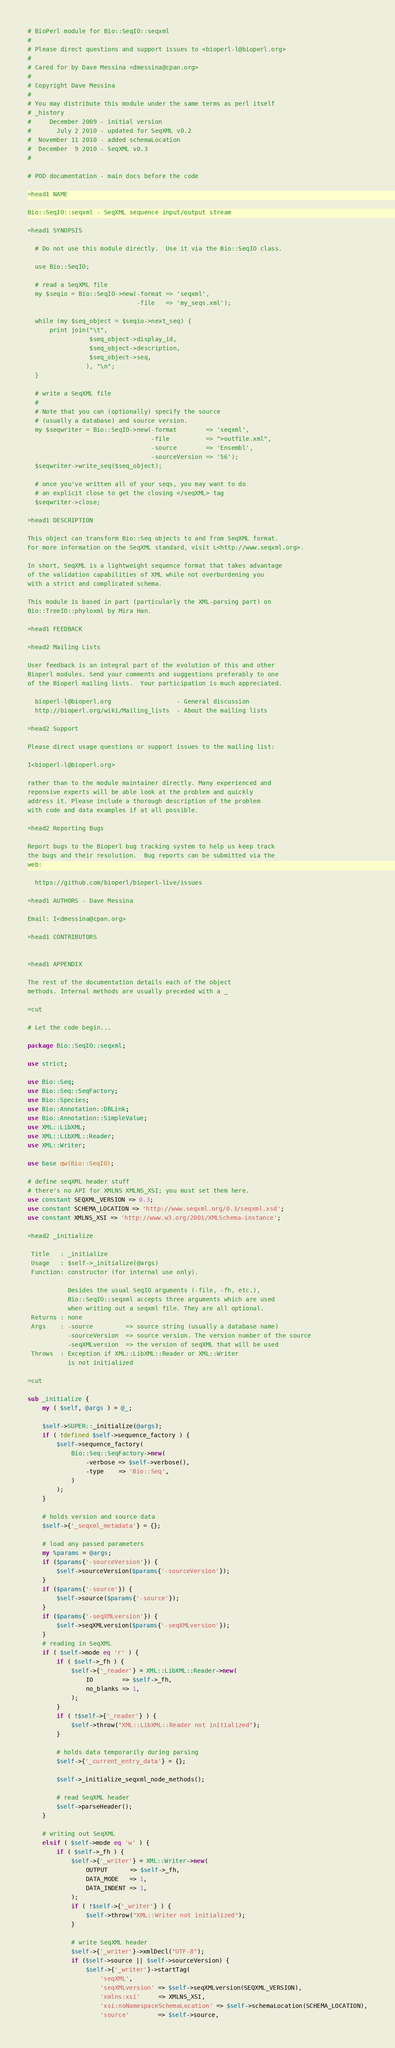Convert code to text. <code><loc_0><loc_0><loc_500><loc_500><_Perl_># BioPerl module for Bio::SeqIO::seqxml
#
# Please direct questions and support issues to <bioperl-l@bioperl.org>
#
# Cared for by Dave Messina <dmessina@cpan.org>
#
# Copyright Dave Messina
#
# You may distribute this module under the same terms as perl itself
# _history
#     December 2009 - initial version
#       July 2 2010 - updated for SeqXML v0.2
#  November 11 2010 - added schemaLocation
#  December  9 2010 - SeqXML v0.3
# 

# POD documentation - main docs before the code

=head1 NAME

Bio::SeqIO::seqxml - SeqXML sequence input/output stream

=head1 SYNOPSIS

  # Do not use this module directly.  Use it via the Bio::SeqIO class.

  use Bio::SeqIO;
  
  # read a SeqXML file
  my $seqio = Bio::SeqIO->new(-format => 'seqxml',
                              -file   => 'my_seqs.xml');

  while (my $seq_object = $seqio->next_seq) {
      print join("\t", 
                 $seq_object->display_id,
                 $seq_object->description,
                 $seq_object->seq,           
                ), "\n";
  }
  
  # write a SeqXML file
  #
  # Note that you can (optionally) specify the source
  # (usually a database) and source version.
  my $seqwriter = Bio::SeqIO->new(-format        => 'seqxml',
                                  -file          => ">outfile.xml",
                                  -source        => 'Ensembl',
                                  -sourceVersion => '56');
  $seqwriter->write_seq($seq_object);

  # once you've written all of your seqs, you may want to do
  # an explicit close to get the closing </seqXML> tag
  $seqwriter->close; 

=head1 DESCRIPTION

This object can transform Bio::Seq objects to and from SeqXML format.
For more information on the SeqXML standard, visit L<http://www.seqxml.org>.

In short, SeqXML is a lightweight sequence format that takes advantage
of the validation capabilities of XML while not overburdening you
with a strict and complicated schema.

This module is based in part (particularly the XML-parsing part) on 
Bio::TreeIO::phyloxml by Mira Han.

=head1 FEEDBACK

=head2 Mailing Lists

User feedback is an integral part of the evolution of this and other
Bioperl modules. Send your comments and suggestions preferably to one
of the Bioperl mailing lists.  Your participation is much appreciated.

  bioperl-l@bioperl.org                  - General discussion
  http://bioperl.org/wiki/Mailing_lists  - About the mailing lists

=head2 Support 

Please direct usage questions or support issues to the mailing list:

I<bioperl-l@bioperl.org>

rather than to the module maintainer directly. Many experienced and 
reponsive experts will be able look at the problem and quickly 
address it. Please include a thorough description of the problem 
with code and data examples if at all possible.

=head2 Reporting Bugs

Report bugs to the Bioperl bug tracking system to help us keep track
the bugs and their resolution.  Bug reports can be submitted via the
web:

  https://github.com/bioperl/bioperl-live/issues

=head1 AUTHORS - Dave Messina

Email: I<dmessina@cpan.org>

=head1 CONTRIBUTORS


=head1 APPENDIX

The rest of the documentation details each of the object
methods. Internal methods are usually preceded with a _

=cut

# Let the code begin...

package Bio::SeqIO::seqxml;

use strict;

use Bio::Seq;
use Bio::Seq::SeqFactory;
use Bio::Species;
use Bio::Annotation::DBLink;
use Bio::Annotation::SimpleValue;
use XML::LibXML;
use XML::LibXML::Reader;
use XML::Writer;

use base qw(Bio::SeqIO);

# define seqXML header stuff
# there's no API for XMLNS XMLNS_XSI; you must set them here.
use constant SEQXML_VERSION => 0.3;
use constant SCHEMA_LOCATION => 'http://www.seqxml.org/0.3/seqxml.xsd';
use constant XMLNS_XSI => 'http://www.w3.org/2001/XMLSchema-instance';

=head2 _initialize

 Title   : _initialize
 Usage   : $self->_initialize(@args) 
 Function: constructor (for internal use only).
 
           Besides the usual SeqIO arguments (-file, -fh, etc.),
           Bio::SeqIO::seqxml accepts three arguments which are used
           when writing out a seqxml file. They are all optional.
 Returns : none
 Args    : -source         => source string (usually a database name)
           -sourceVersion  => source version. The version number of the source
           -seqXMLversion  => the version of seqXML that will be used
 Throws  : Exception if XML::LibXML::Reader or XML::Writer
           is not initialized

=cut

sub _initialize {
    my ( $self, @args ) = @_;

    $self->SUPER::_initialize(@args);
    if ( !defined $self->sequence_factory ) {
        $self->sequence_factory(
            Bio::Seq::SeqFactory->new(
                -verbose => $self->verbose(),
                -type    => 'Bio::Seq',
            )
        );
    }

    # holds version and source data
    $self->{'_seqxml_metadata'} = {};

    # load any passed parameters
    my %params = @args;
    if ($params{'-sourceVersion'}) {
        $self->sourceVersion($params{'-sourceVersion'});
    }
    if ($params{'-source'}) {
        $self->source($params{'-source'});
    }
    if ($params{'-seqXMLversion'}) {
        $self->seqXMLversion($params{'-seqXMLversion'});
    }
    # reading in SeqXML
    if ( $self->mode eq 'r' ) {
        if ( $self->_fh ) {
            $self->{'_reader'} = XML::LibXML::Reader->new(
                IO        => $self->_fh,
                no_blanks => 1,
            );
        }
        if ( !$self->{'_reader'} ) {
            $self->throw("XML::LibXML::Reader not initialized");
        }

        # holds data temporarily during parsing
        $self->{'_current_entry_data'} = {};

        $self->_initialize_seqxml_node_methods();
        
        # read SeqXML header
        $self->parseHeader();
    }

    # writing out SeqXML
    elsif ( $self->mode eq 'w' ) {
        if ( $self->_fh ) {
            $self->{'_writer'} = XML::Writer->new(
                OUTPUT      => $self->_fh,
                DATA_MODE   => 1,
                DATA_INDENT => 1,
            );
            if ( !$self->{'_writer'} ) {
                $self->throw("XML::Writer not initialized");
            }

            # write SeqXML header
            $self->{'_writer'}->xmlDecl("UTF-8");
            if ($self->source || $self->sourceVersion) {
                $self->{'_writer'}->startTag(
                    'seqXML',
                    'seqXMLversion' => $self->seqXMLversion(SEQXML_VERSION),
                    'xmlns:xsi'     => XMLNS_XSI,
                    'xsi:noNamespaceSchemaLocation' => $self->schemaLocation(SCHEMA_LOCATION),
                    'source'        => $self->source,</code> 